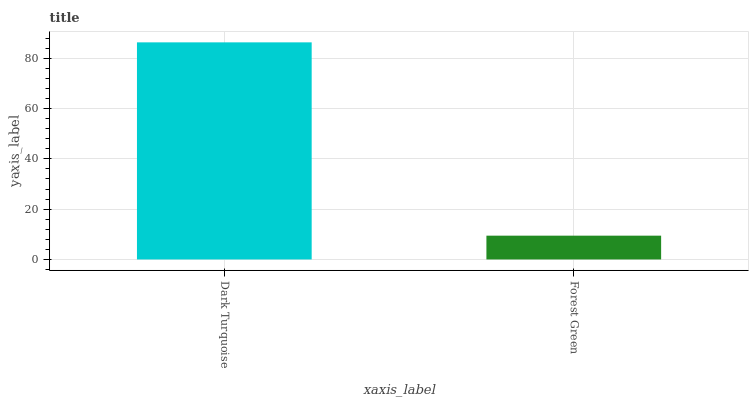Is Forest Green the minimum?
Answer yes or no. Yes. Is Dark Turquoise the maximum?
Answer yes or no. Yes. Is Forest Green the maximum?
Answer yes or no. No. Is Dark Turquoise greater than Forest Green?
Answer yes or no. Yes. Is Forest Green less than Dark Turquoise?
Answer yes or no. Yes. Is Forest Green greater than Dark Turquoise?
Answer yes or no. No. Is Dark Turquoise less than Forest Green?
Answer yes or no. No. Is Dark Turquoise the high median?
Answer yes or no. Yes. Is Forest Green the low median?
Answer yes or no. Yes. Is Forest Green the high median?
Answer yes or no. No. Is Dark Turquoise the low median?
Answer yes or no. No. 